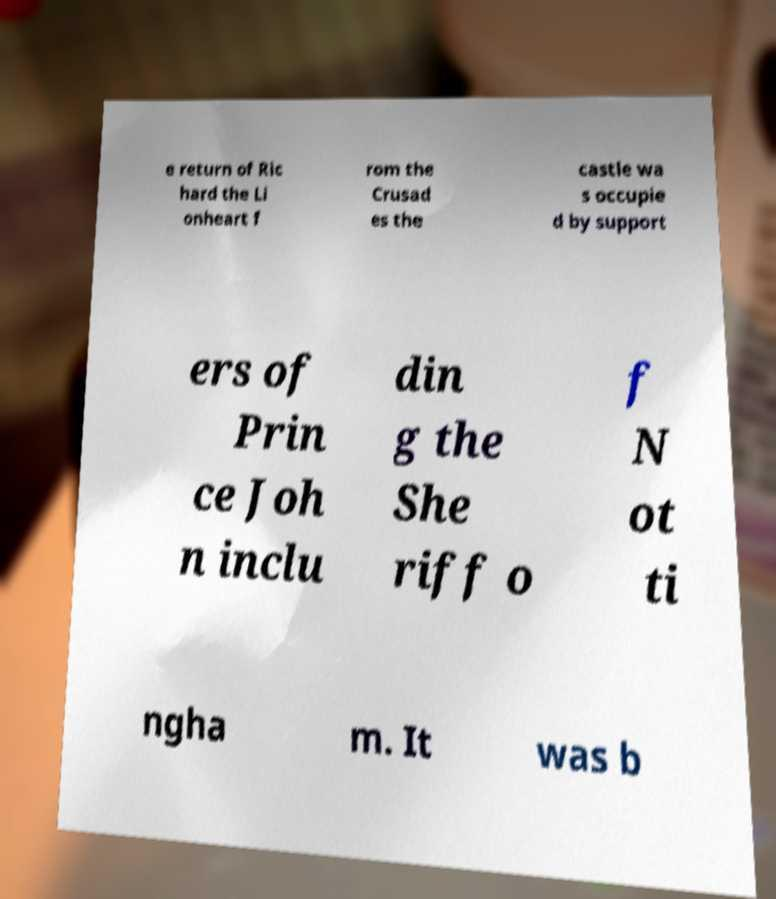Can you read and provide the text displayed in the image?This photo seems to have some interesting text. Can you extract and type it out for me? e return of Ric hard the Li onheart f rom the Crusad es the castle wa s occupie d by support ers of Prin ce Joh n inclu din g the She riff o f N ot ti ngha m. It was b 